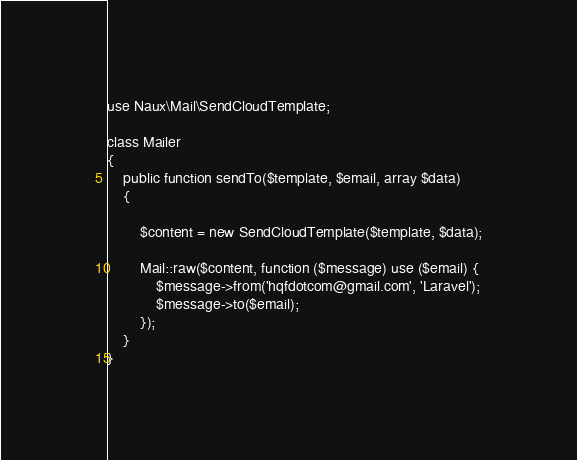<code> <loc_0><loc_0><loc_500><loc_500><_PHP_>use Naux\Mail\SendCloudTemplate;

class Mailer
{
    public function sendTo($template, $email, array $data)
    {

        $content = new SendCloudTemplate($template, $data);

        Mail::raw($content, function ($message) use ($email) {
            $message->from('hqfdotcom@gmail.com', 'Laravel');
            $message->to($email);
        });
    }
}</code> 